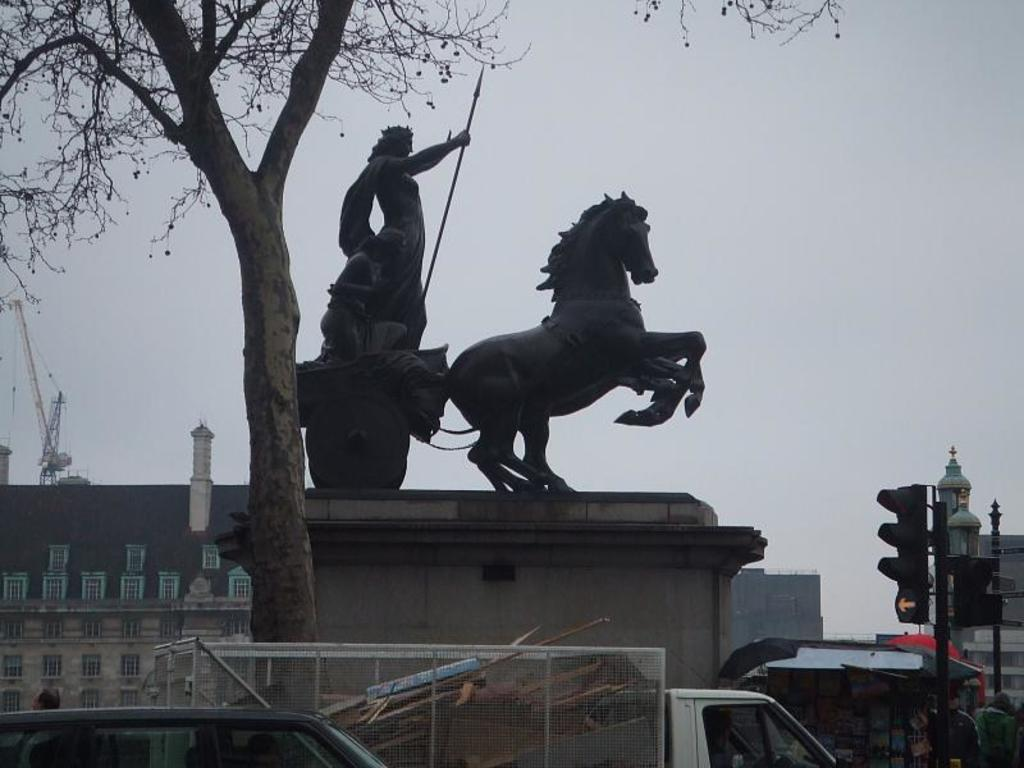What type of structures can be seen in the image? There are statues and a building in the image. What is being used for construction purposes in the image? Construction cranes are visible in the image. What type of vegetation is present in the image? There is a tree in the image. What type of transportation is present on the road in the image? Motor vehicles are present on the road in the image. What type of infrastructure is present in the image? Traffic poles and traffic signals are visible in the image. What part of the natural environment is visible in the image? The sky is visible in the image. What type of pencil can be seen in the image? There is no pencil present in the image. What is the opinion of the statues in the image? The image does not convey any opinions about the statues; it simply shows their presence. 